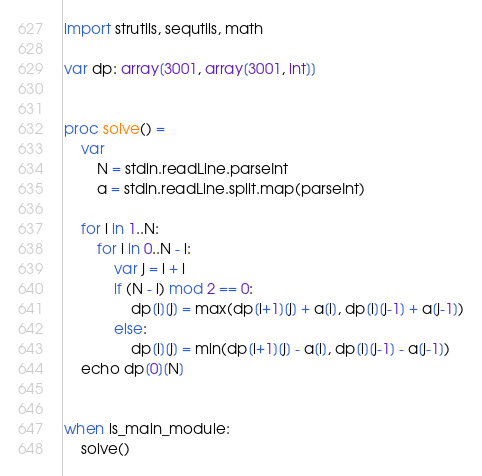Convert code to text. <code><loc_0><loc_0><loc_500><loc_500><_Nim_>import strutils, sequtils, math

var dp: array[3001, array[3001, int]]


proc solve() =
    var
        N = stdin.readLine.parseInt
        a = stdin.readLine.split.map(parseInt)
    
    for l in 1..N:
        for i in 0..N - l:
            var j = i + l
            if (N - l) mod 2 == 0:
                dp[i][j] = max(dp[i+1][j] + a[i], dp[i][j-1] + a[j-1])
            else:
                dp[i][j] = min(dp[i+1][j] - a[i], dp[i][j-1] - a[j-1])
    echo dp[0][N]


when is_main_module:
    solve()
</code> 